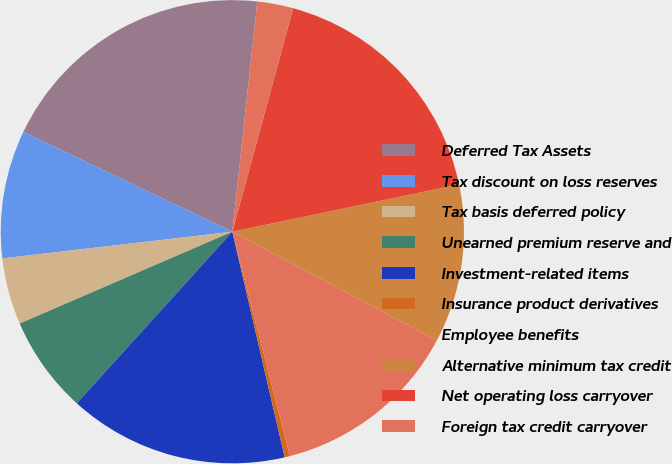Convert chart to OTSL. <chart><loc_0><loc_0><loc_500><loc_500><pie_chart><fcel>Deferred Tax Assets<fcel>Tax discount on loss reserves<fcel>Tax basis deferred policy<fcel>Unearned premium reserve and<fcel>Investment-related items<fcel>Insurance product derivatives<fcel>Employee benefits<fcel>Alternative minimum tax credit<fcel>Net operating loss carryover<fcel>Foreign tax credit carryover<nl><fcel>19.63%<fcel>8.93%<fcel>4.65%<fcel>6.79%<fcel>15.35%<fcel>0.37%<fcel>13.21%<fcel>11.07%<fcel>17.49%<fcel>2.51%<nl></chart> 